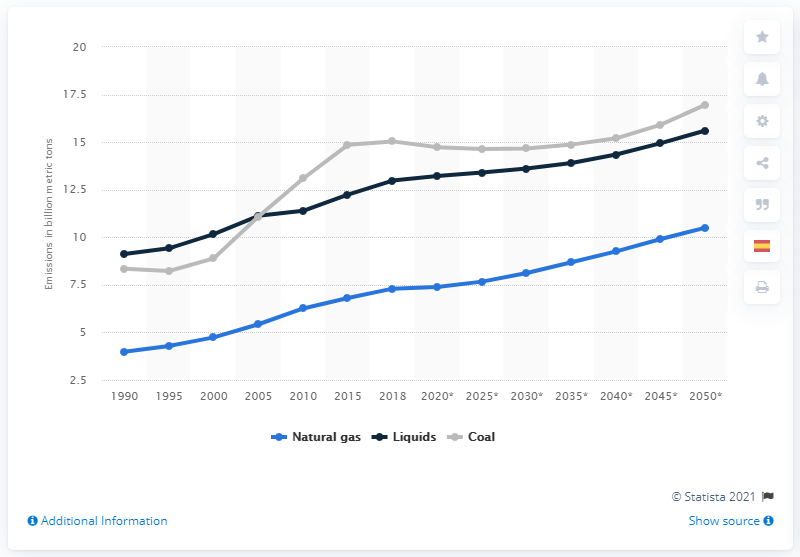Draw attention to some important aspects in this diagram. Energy-related CO2 emissions from natural gas, liquids, and coal have steadily increased since 1990. 